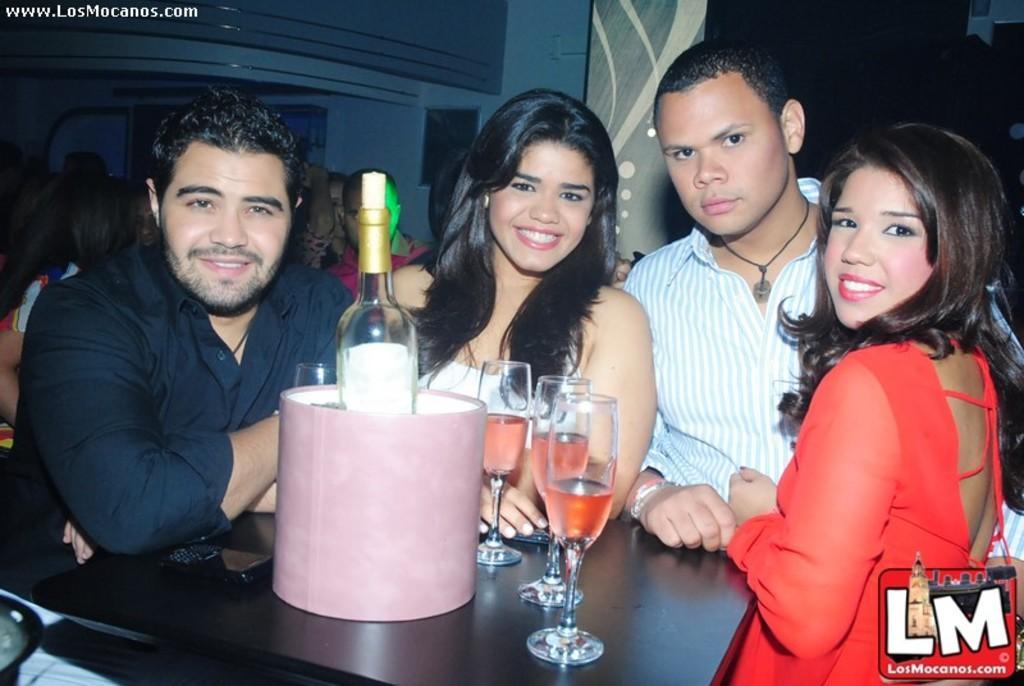In one or two sentences, can you explain what this image depicts? In this image there is a table, on that table there are glasses and a bottle, around the table there are people standing and a man is sitting a chair, in the background there are people, in the bottom right there is a logo and text, in the top left there is some text. 